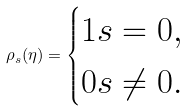<formula> <loc_0><loc_0><loc_500><loc_500>\rho _ { s } ( \eta ) = \begin{cases} 1 s = 0 , \\ 0 s \neq 0 . \end{cases}</formula> 